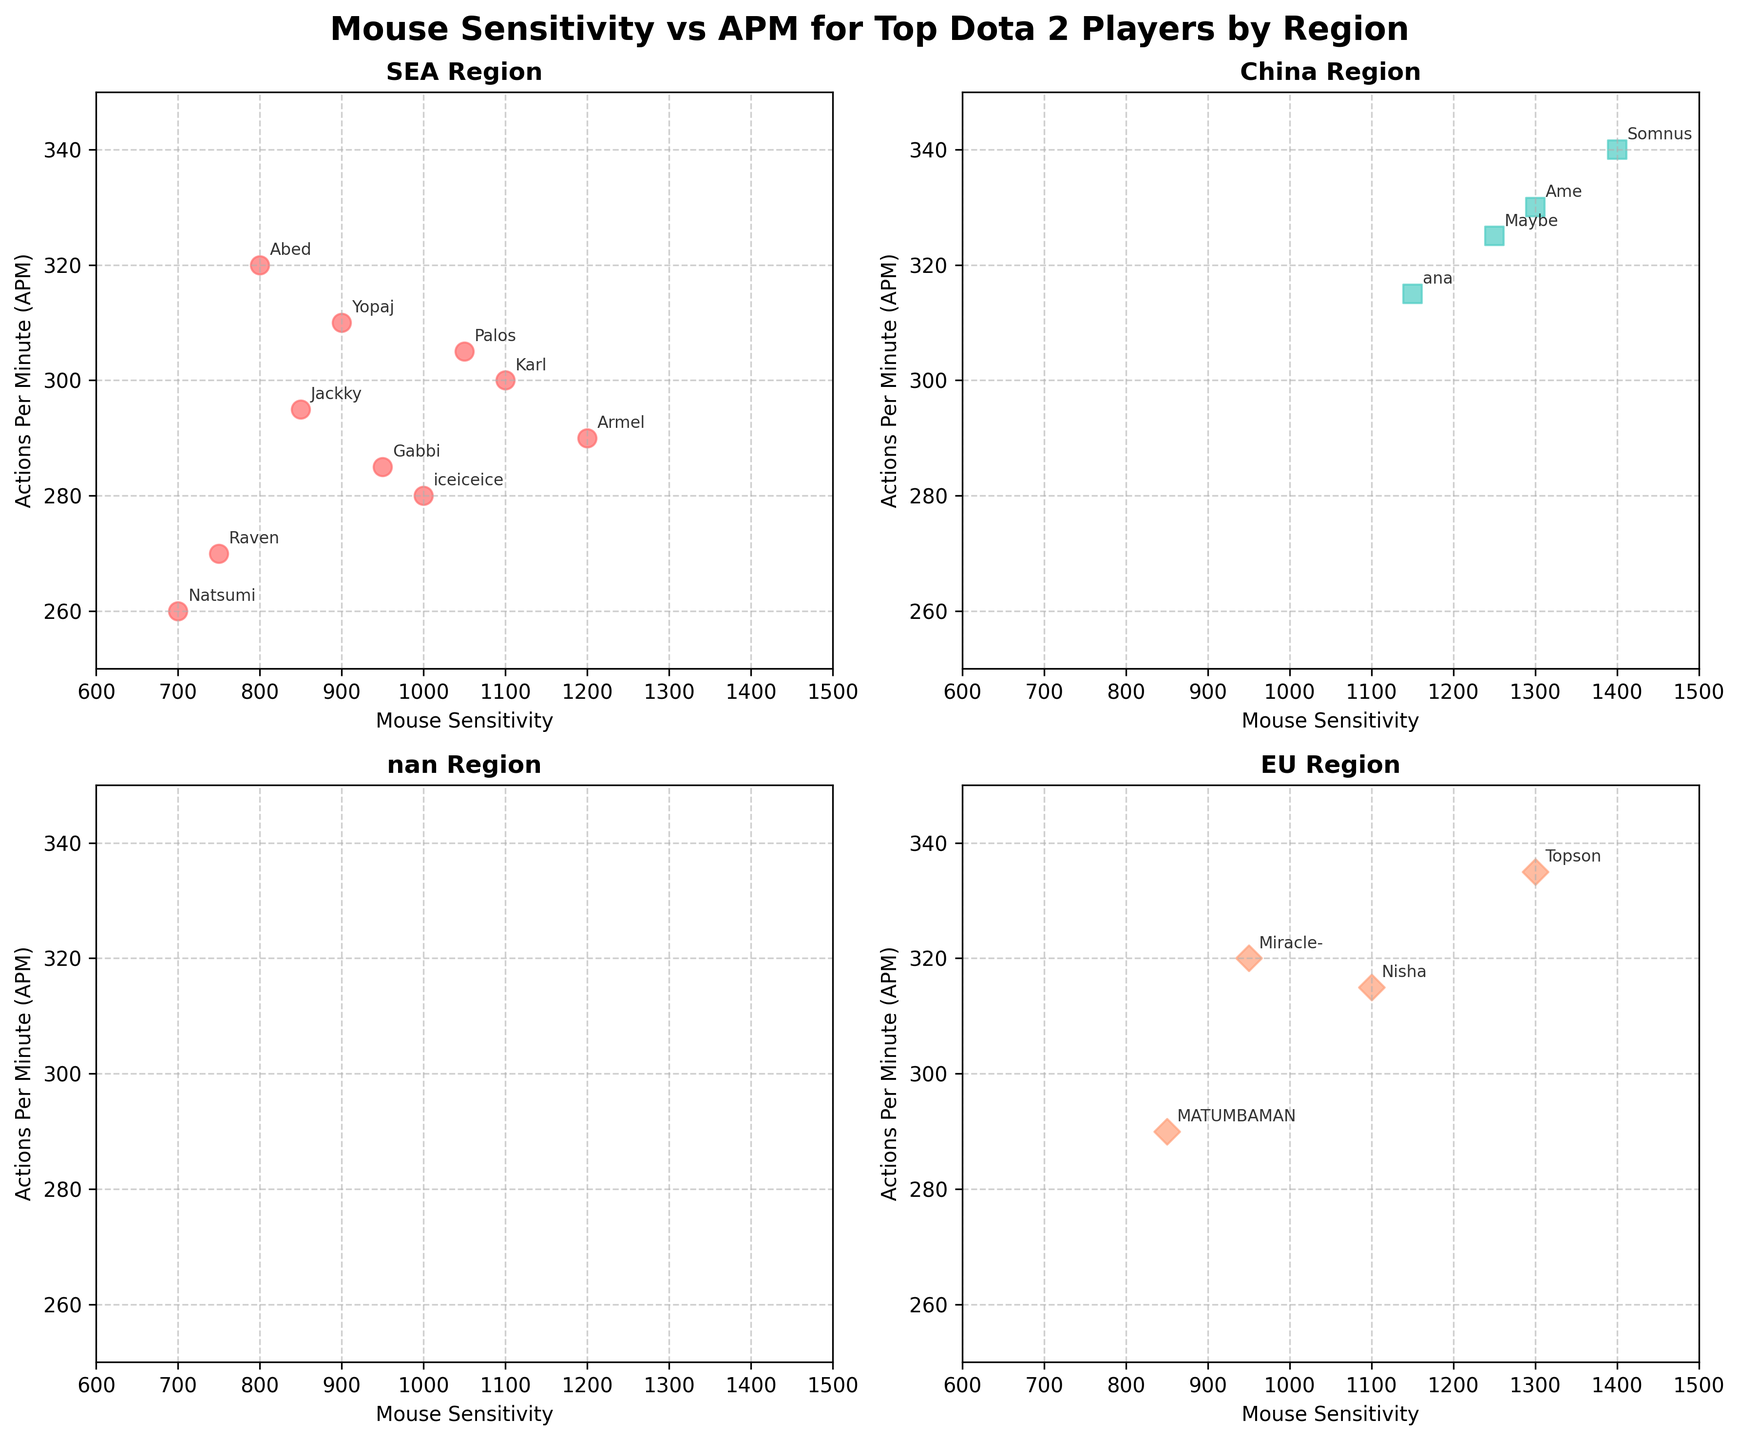Which region has the highest mouse sensitivity setting among its players? The China region has players with mouse sensitivity settings up to 1400, which is the highest among all regions.
Answer: China Which player has the lowest APM in the SEA region? Natsumi in the SEA region has the lowest APM of 260.
Answer: Natsumi How many players are in the EU region? There are 4 players in the EU region: Miracle-, Nisha, MATUMBAMAN, and Topson.
Answer: 4 Which region shows the highest APM overall? The China region has the highest APM with Somnus reaching up to 340.
Answer: China What is the average mouse sensitivity setting for players in the NA region? Arteezy has a sensitivity of 1000 and SumaiL has 1200. Their average sensitivity is (1000 + 1200) / 2 = 1100.
Answer: 1100 Who in the SEA region has the closest APM to 300? Both Karl and Gabbi in the SEA region have an APM close to 300, but Karl's 300 is exact.
Answer: Karl Among EU players, who has the highest mouse sensitivity setting? Topson has the highest mouse sensitivity setting in the EU region with 1300.
Answer: Topson Which regions have players with an APM greater than or equal to 330? Both China and EU regions have players with an APM equal to or greater than 330. Somnus and Ame (China), Topson (EU).
Answer: China and EU 